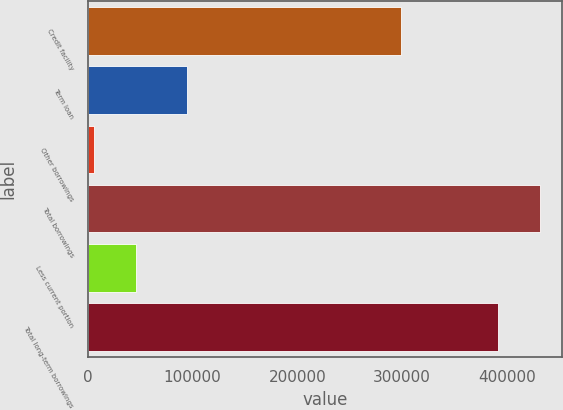Convert chart. <chart><loc_0><loc_0><loc_500><loc_500><bar_chart><fcel>Credit facility<fcel>Term loan<fcel>Other borrowings<fcel>Total borrowings<fcel>Less current portion<fcel>Total long-term borrowings<nl><fcel>298732<fcel>95000<fcel>6368<fcel>431127<fcel>45741.2<fcel>391754<nl></chart> 